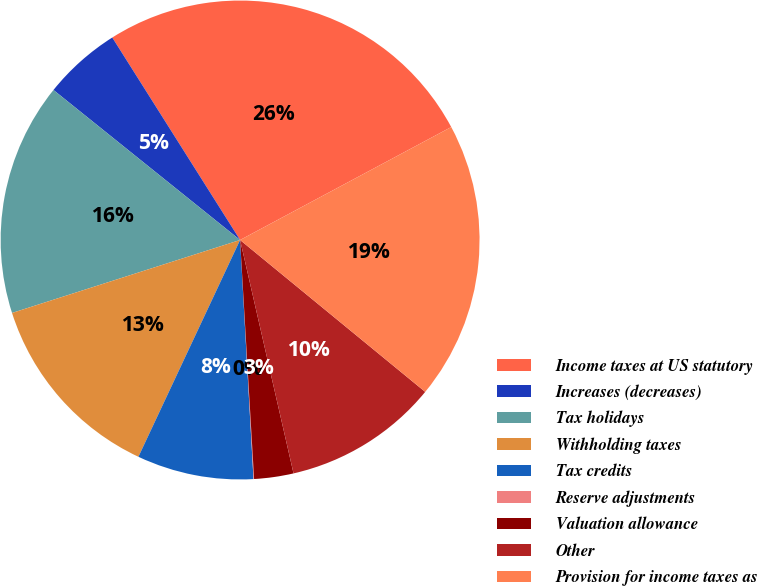Convert chart. <chart><loc_0><loc_0><loc_500><loc_500><pie_chart><fcel>Income taxes at US statutory<fcel>Increases (decreases)<fcel>Tax holidays<fcel>Withholding taxes<fcel>Tax credits<fcel>Reserve adjustments<fcel>Valuation allowance<fcel>Other<fcel>Provision for income taxes as<nl><fcel>26.14%<fcel>5.26%<fcel>15.7%<fcel>13.09%<fcel>7.87%<fcel>0.04%<fcel>2.65%<fcel>10.48%<fcel>18.75%<nl></chart> 